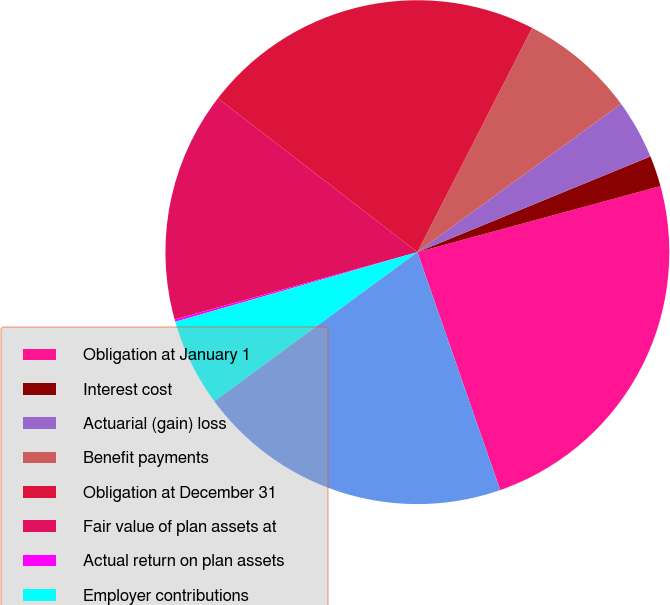Convert chart to OTSL. <chart><loc_0><loc_0><loc_500><loc_500><pie_chart><fcel>Obligation at January 1<fcel>Interest cost<fcel>Actuarial (gain) loss<fcel>Benefit payments<fcel>Obligation at December 31<fcel>Fair value of plan assets at<fcel>Actual return on plan assets<fcel>Employer contributions<fcel>Funded status at December 31<nl><fcel>23.89%<fcel>1.98%<fcel>3.81%<fcel>7.46%<fcel>22.07%<fcel>14.76%<fcel>0.15%<fcel>5.63%<fcel>20.24%<nl></chart> 